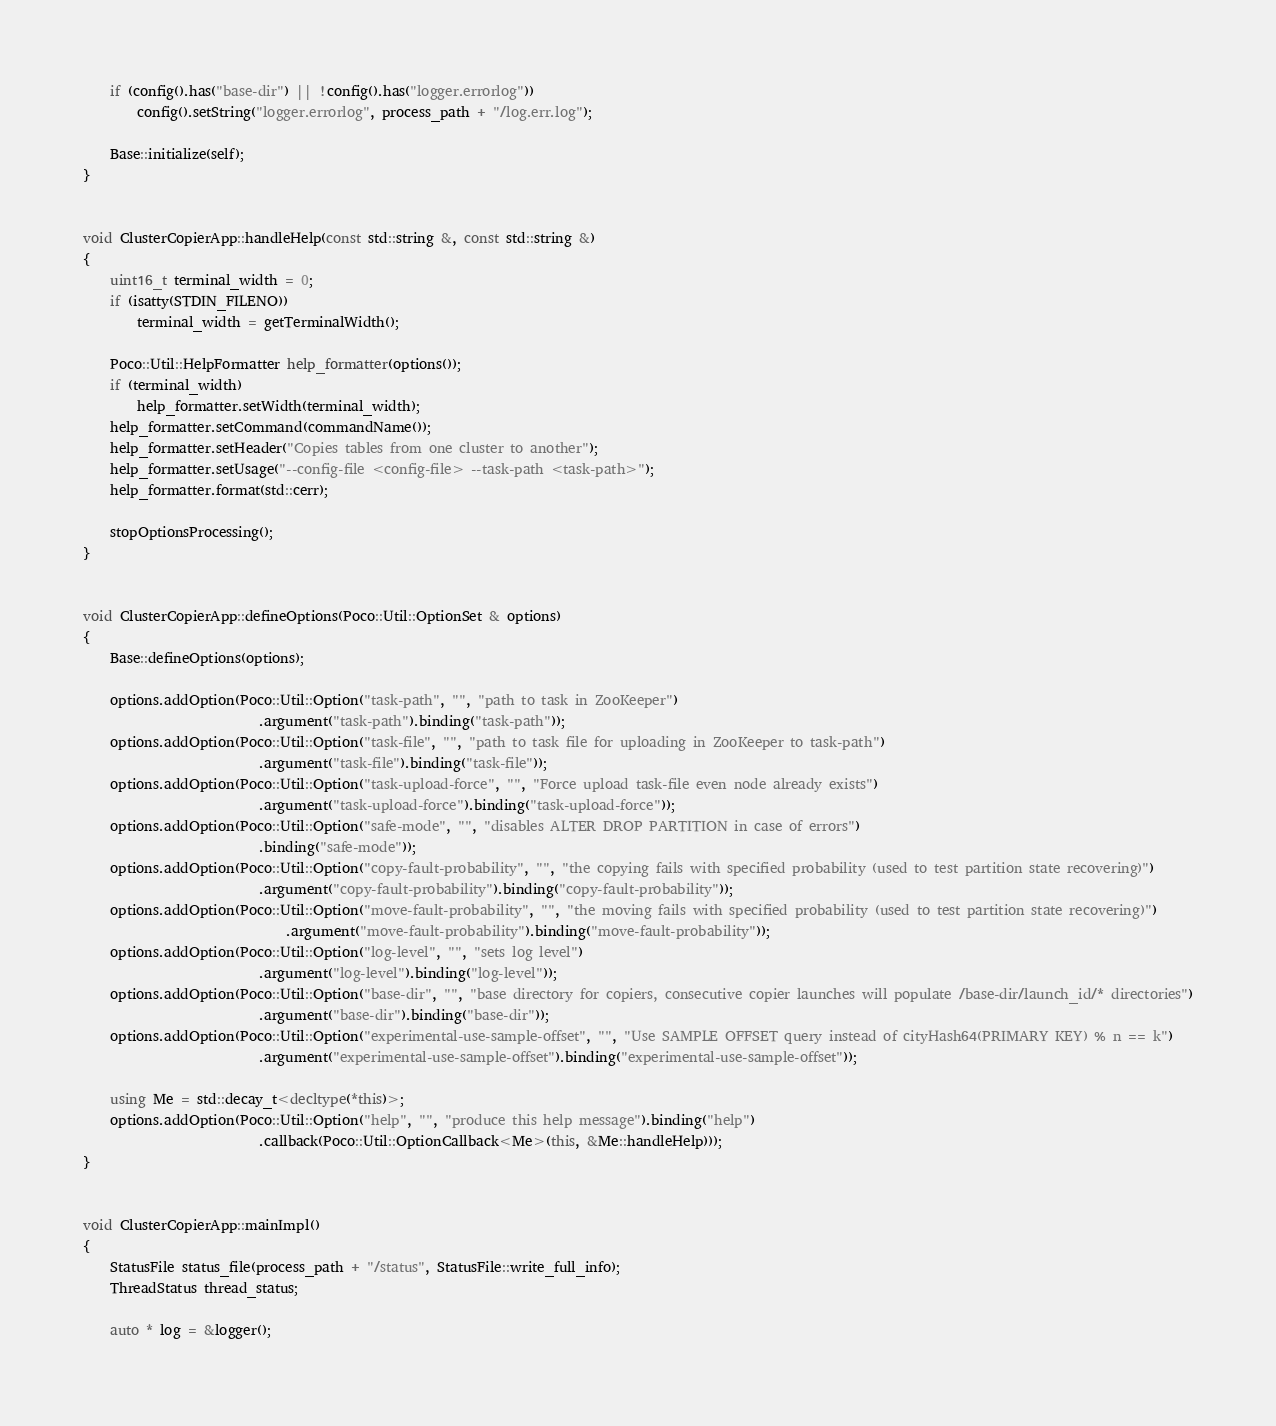<code> <loc_0><loc_0><loc_500><loc_500><_C++_>
    if (config().has("base-dir") || !config().has("logger.errorlog"))
        config().setString("logger.errorlog", process_path + "/log.err.log");

    Base::initialize(self);
}


void ClusterCopierApp::handleHelp(const std::string &, const std::string &)
{
    uint16_t terminal_width = 0;
    if (isatty(STDIN_FILENO))
        terminal_width = getTerminalWidth();

    Poco::Util::HelpFormatter help_formatter(options());
    if (terminal_width)
        help_formatter.setWidth(terminal_width);
    help_formatter.setCommand(commandName());
    help_formatter.setHeader("Copies tables from one cluster to another");
    help_formatter.setUsage("--config-file <config-file> --task-path <task-path>");
    help_formatter.format(std::cerr);

    stopOptionsProcessing();
}


void ClusterCopierApp::defineOptions(Poco::Util::OptionSet & options)
{
    Base::defineOptions(options);

    options.addOption(Poco::Util::Option("task-path", "", "path to task in ZooKeeper")
                          .argument("task-path").binding("task-path"));
    options.addOption(Poco::Util::Option("task-file", "", "path to task file for uploading in ZooKeeper to task-path")
                          .argument("task-file").binding("task-file"));
    options.addOption(Poco::Util::Option("task-upload-force", "", "Force upload task-file even node already exists")
                          .argument("task-upload-force").binding("task-upload-force"));
    options.addOption(Poco::Util::Option("safe-mode", "", "disables ALTER DROP PARTITION in case of errors")
                          .binding("safe-mode"));
    options.addOption(Poco::Util::Option("copy-fault-probability", "", "the copying fails with specified probability (used to test partition state recovering)")
                          .argument("copy-fault-probability").binding("copy-fault-probability"));
    options.addOption(Poco::Util::Option("move-fault-probability", "", "the moving fails with specified probability (used to test partition state recovering)")
                              .argument("move-fault-probability").binding("move-fault-probability"));
    options.addOption(Poco::Util::Option("log-level", "", "sets log level")
                          .argument("log-level").binding("log-level"));
    options.addOption(Poco::Util::Option("base-dir", "", "base directory for copiers, consecutive copier launches will populate /base-dir/launch_id/* directories")
                          .argument("base-dir").binding("base-dir"));
    options.addOption(Poco::Util::Option("experimental-use-sample-offset", "", "Use SAMPLE OFFSET query instead of cityHash64(PRIMARY KEY) % n == k")
                          .argument("experimental-use-sample-offset").binding("experimental-use-sample-offset"));

    using Me = std::decay_t<decltype(*this)>;
    options.addOption(Poco::Util::Option("help", "", "produce this help message").binding("help")
                          .callback(Poco::Util::OptionCallback<Me>(this, &Me::handleHelp)));
}


void ClusterCopierApp::mainImpl()
{
    StatusFile status_file(process_path + "/status", StatusFile::write_full_info);
    ThreadStatus thread_status;

    auto * log = &logger();</code> 